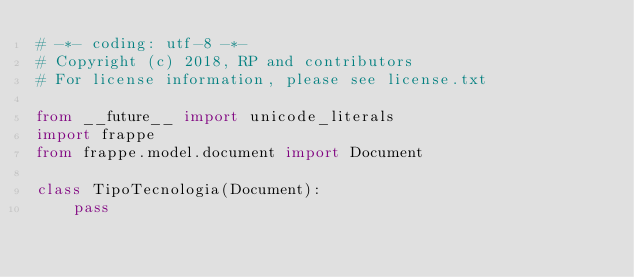<code> <loc_0><loc_0><loc_500><loc_500><_Python_># -*- coding: utf-8 -*-
# Copyright (c) 2018, RP and contributors
# For license information, please see license.txt

from __future__ import unicode_literals
import frappe
from frappe.model.document import Document

class TipoTecnologia(Document):
	pass
</code> 